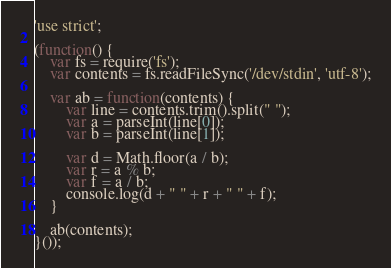<code> <loc_0><loc_0><loc_500><loc_500><_JavaScript_>'use strict';

(function() {
    var fs = require('fs');
    var contents = fs.readFileSync('/dev/stdin', 'utf-8');

    var ab = function(contents) {
        var line = contents.trim().split(" ");
        var a = parseInt(line[0]);
        var b = parseInt(line[1]);

        var d = Math.floor(a / b);
        var r = a % b;
        var f = a / b;
        console.log(d + " " + r + " " + f);
    }

    ab(contents);
}());</code> 